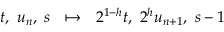Convert formula to latex. <formula><loc_0><loc_0><loc_500><loc_500>t , \ u _ { n } , \ s \quad m a p s t o \ \ 2 ^ { 1 - h } t , \ 2 ^ { h } u _ { n + 1 } , \ s - 1</formula> 